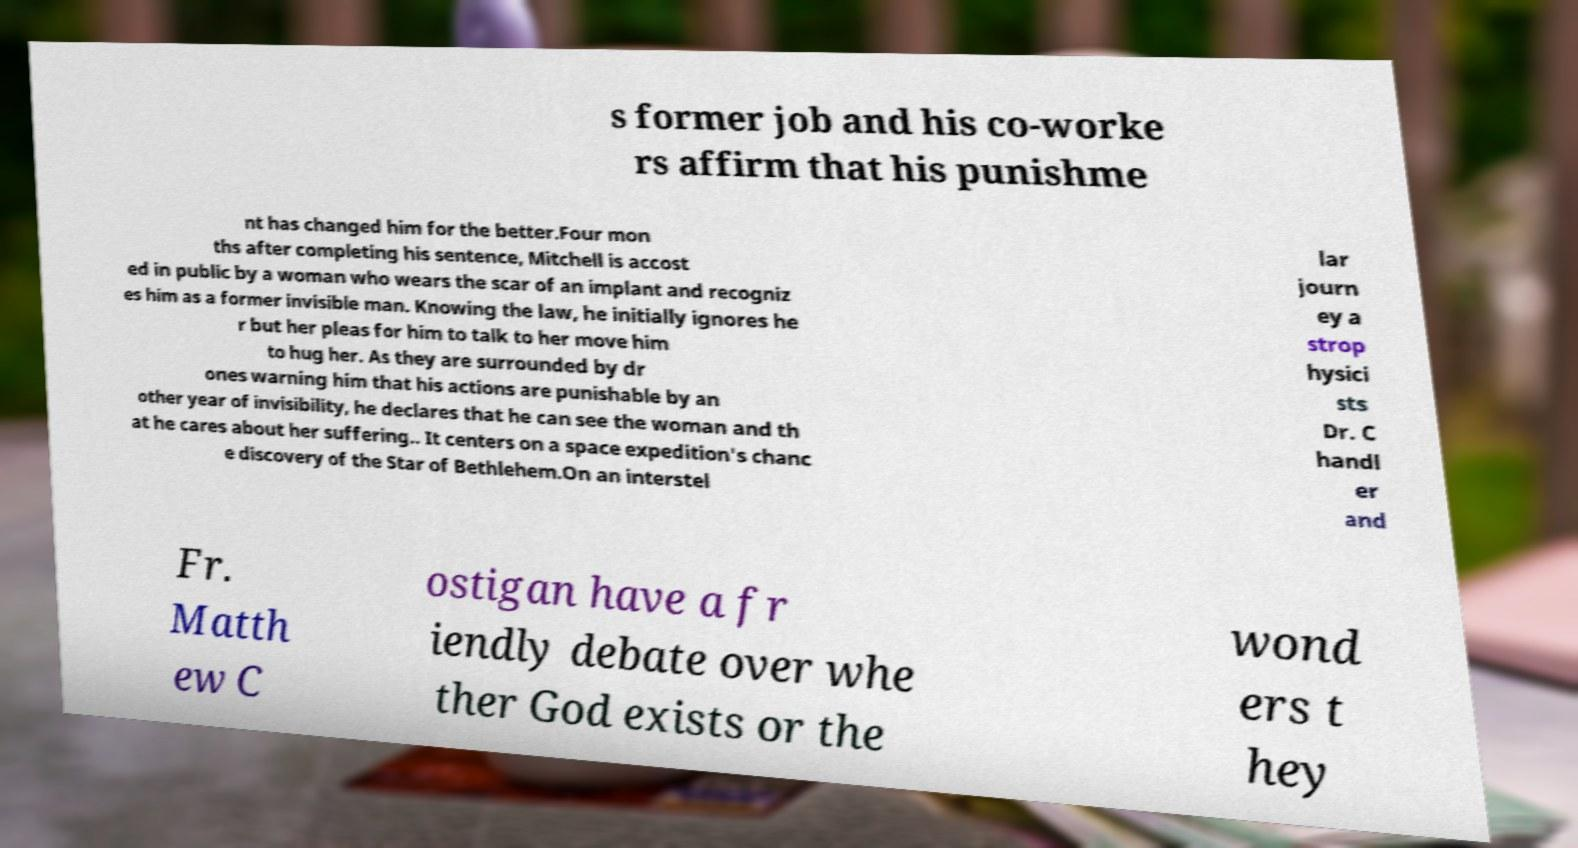What messages or text are displayed in this image? I need them in a readable, typed format. s former job and his co-worke rs affirm that his punishme nt has changed him for the better.Four mon ths after completing his sentence, Mitchell is accost ed in public by a woman who wears the scar of an implant and recogniz es him as a former invisible man. Knowing the law, he initially ignores he r but her pleas for him to talk to her move him to hug her. As they are surrounded by dr ones warning him that his actions are punishable by an other year of invisibility, he declares that he can see the woman and th at he cares about her suffering.. It centers on a space expedition's chanc e discovery of the Star of Bethlehem.On an interstel lar journ ey a strop hysici sts Dr. C handl er and Fr. Matth ew C ostigan have a fr iendly debate over whe ther God exists or the wond ers t hey 